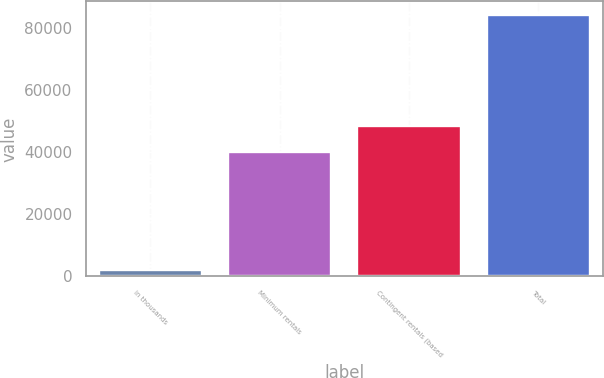Convert chart. <chart><loc_0><loc_0><loc_500><loc_500><bar_chart><fcel>in thousands<fcel>Minimum rentals<fcel>Contingent rentals (based<fcel>Total<nl><fcel>2013<fcel>40151<fcel>48375.9<fcel>84262<nl></chart> 